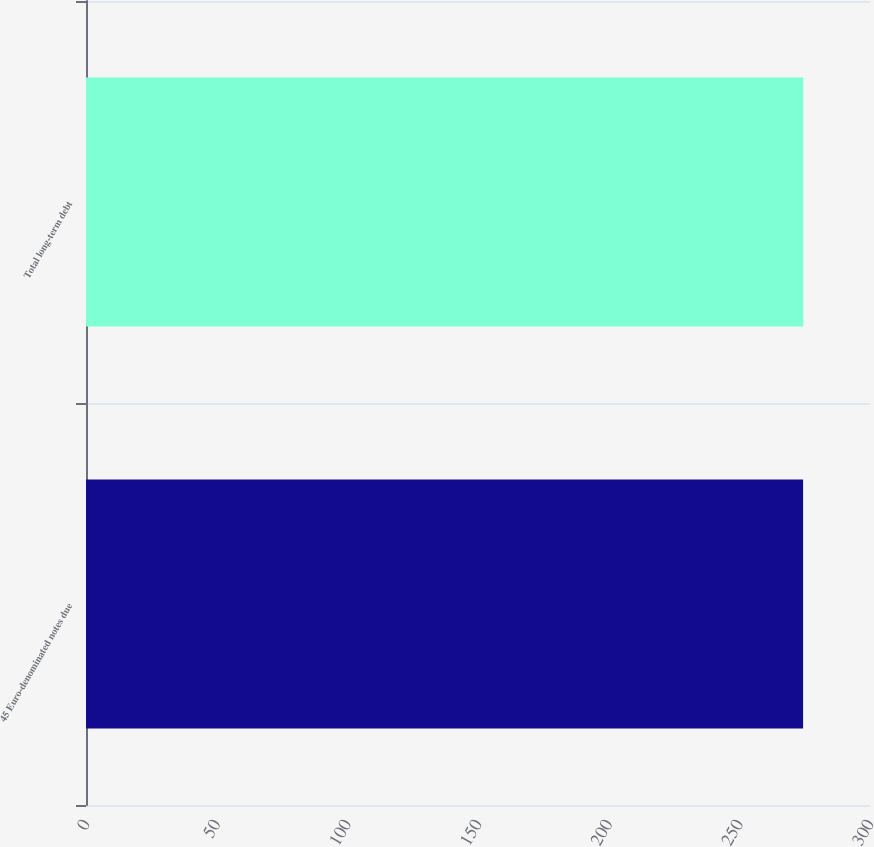Convert chart to OTSL. <chart><loc_0><loc_0><loc_500><loc_500><bar_chart><fcel>45 Euro-denominated notes due<fcel>Total long-term debt<nl><fcel>274.4<fcel>274.5<nl></chart> 